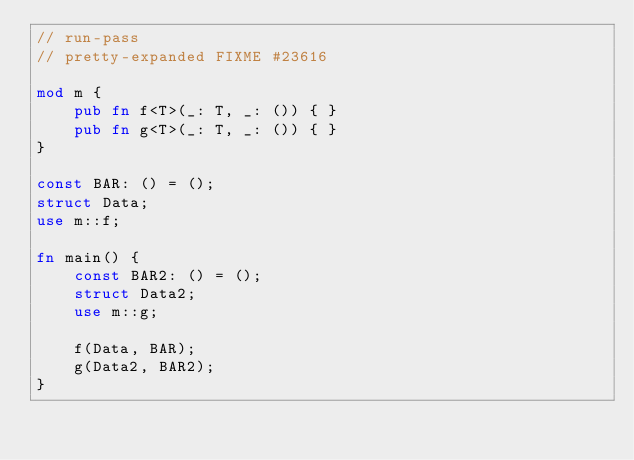Convert code to text. <code><loc_0><loc_0><loc_500><loc_500><_Rust_>// run-pass
// pretty-expanded FIXME #23616

mod m {
    pub fn f<T>(_: T, _: ()) { }
    pub fn g<T>(_: T, _: ()) { }
}

const BAR: () = ();
struct Data;
use m::f;

fn main() {
    const BAR2: () = ();
    struct Data2;
    use m::g;

    f(Data, BAR);
    g(Data2, BAR2);
}
</code> 